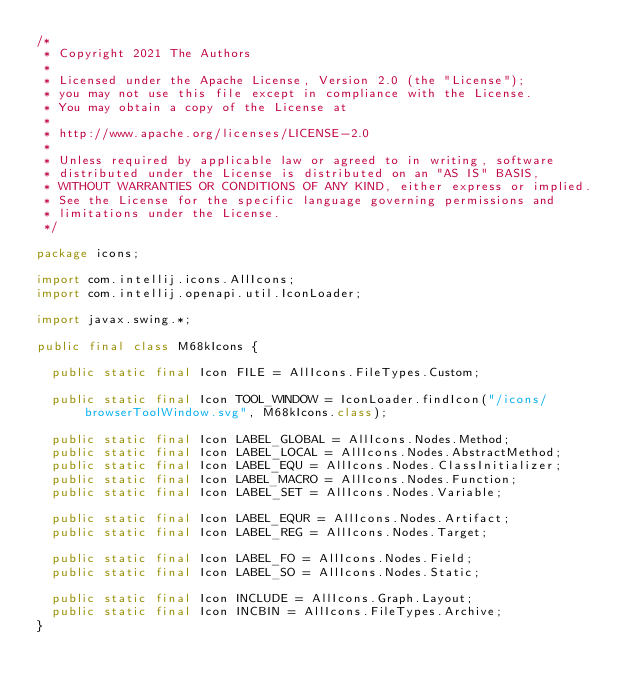<code> <loc_0><loc_0><loc_500><loc_500><_Java_>/*
 * Copyright 2021 The Authors
 *
 * Licensed under the Apache License, Version 2.0 (the "License");
 * you may not use this file except in compliance with the License.
 * You may obtain a copy of the License at
 *
 * http://www.apache.org/licenses/LICENSE-2.0
 *
 * Unless required by applicable law or agreed to in writing, software
 * distributed under the License is distributed on an "AS IS" BASIS,
 * WITHOUT WARRANTIES OR CONDITIONS OF ANY KIND, either express or implied.
 * See the License for the specific language governing permissions and
 * limitations under the License.
 */

package icons;

import com.intellij.icons.AllIcons;
import com.intellij.openapi.util.IconLoader;

import javax.swing.*;

public final class M68kIcons {

  public static final Icon FILE = AllIcons.FileTypes.Custom;

  public static final Icon TOOL_WINDOW = IconLoader.findIcon("/icons/browserToolWindow.svg", M68kIcons.class);

  public static final Icon LABEL_GLOBAL = AllIcons.Nodes.Method;
  public static final Icon LABEL_LOCAL = AllIcons.Nodes.AbstractMethod;
  public static final Icon LABEL_EQU = AllIcons.Nodes.ClassInitializer;
  public static final Icon LABEL_MACRO = AllIcons.Nodes.Function;
  public static final Icon LABEL_SET = AllIcons.Nodes.Variable;

  public static final Icon LABEL_EQUR = AllIcons.Nodes.Artifact;
  public static final Icon LABEL_REG = AllIcons.Nodes.Target;

  public static final Icon LABEL_FO = AllIcons.Nodes.Field;
  public static final Icon LABEL_SO = AllIcons.Nodes.Static;

  public static final Icon INCLUDE = AllIcons.Graph.Layout;
  public static final Icon INCBIN = AllIcons.FileTypes.Archive;
}
</code> 